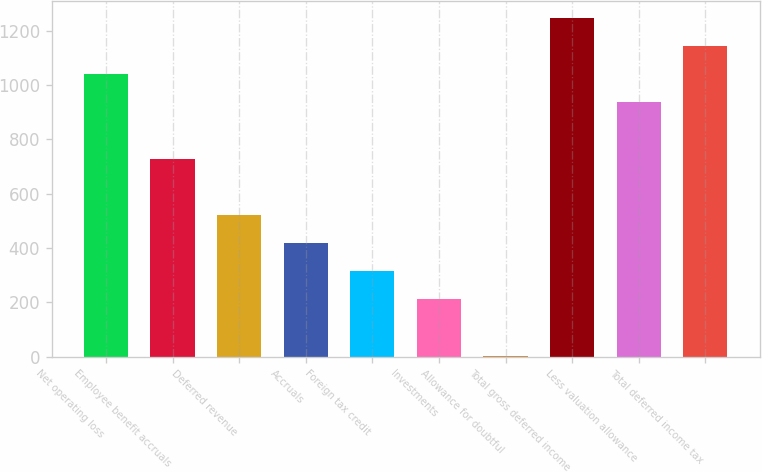<chart> <loc_0><loc_0><loc_500><loc_500><bar_chart><fcel>Net operating loss<fcel>Employee benefit accruals<fcel>Deferred revenue<fcel>Accruals<fcel>Foreign tax credit<fcel>Investments<fcel>Allowance for doubtful<fcel>Total gross deferred income<fcel>Less valuation allowance<fcel>Total deferred income tax<nl><fcel>1040.6<fcel>729.53<fcel>522.15<fcel>418.46<fcel>314.77<fcel>211.08<fcel>3.7<fcel>1247.98<fcel>936.91<fcel>1144.29<nl></chart> 